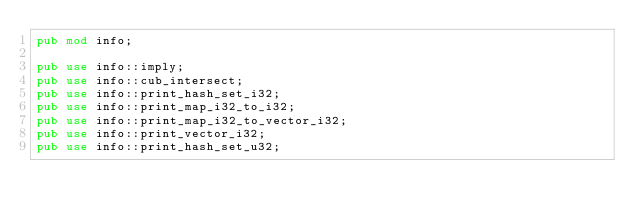<code> <loc_0><loc_0><loc_500><loc_500><_Rust_>pub mod info;

pub use info::imply;
pub use info::cub_intersect;
pub use info::print_hash_set_i32;
pub use info::print_map_i32_to_i32;
pub use info::print_map_i32_to_vector_i32;
pub use info::print_vector_i32;
pub use info::print_hash_set_u32;</code> 